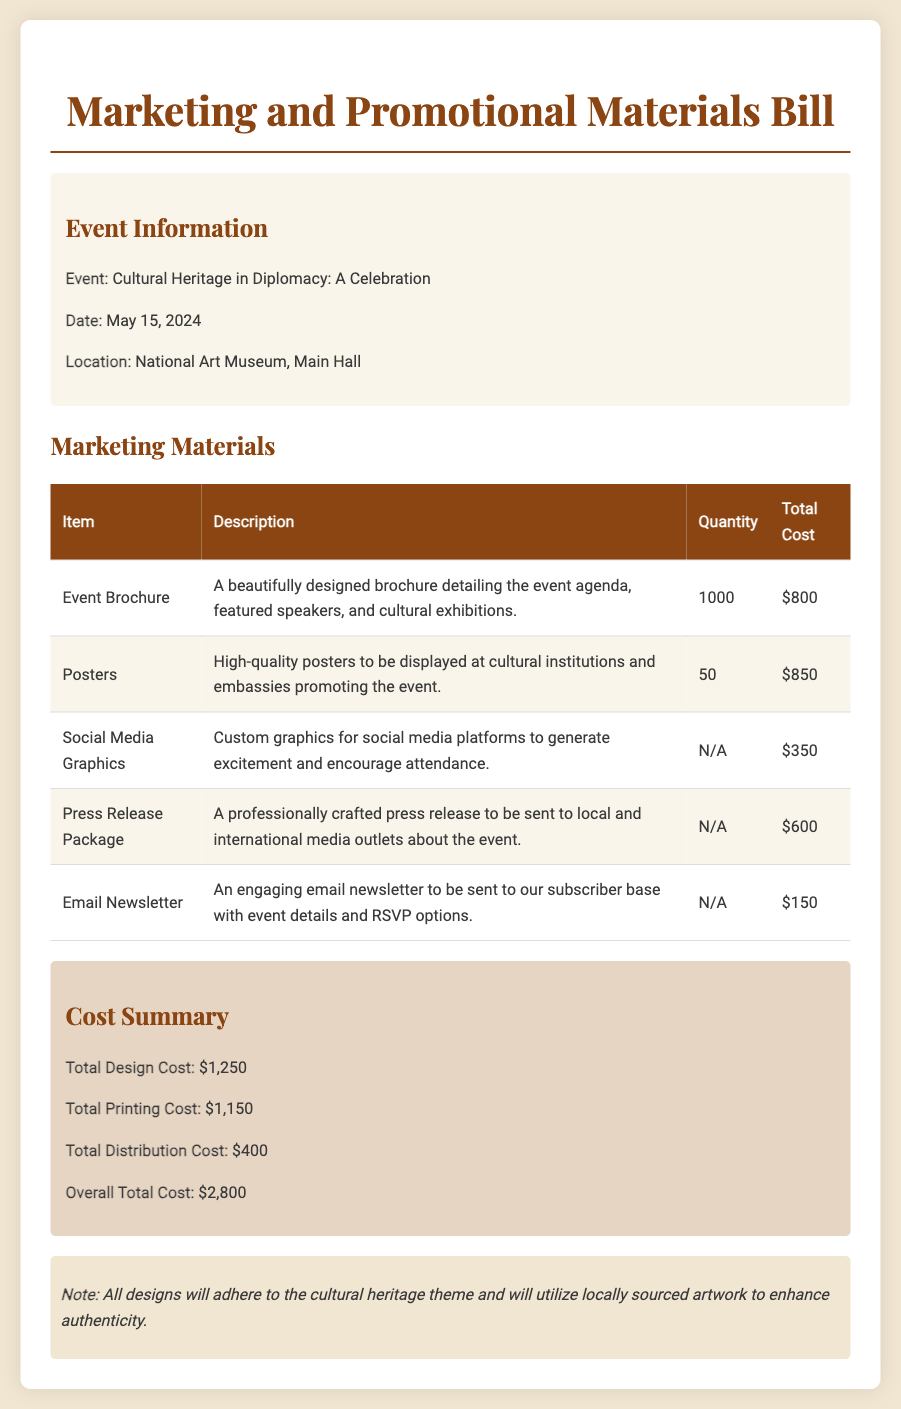What is the event title? The event title is specified in the document as "Cultural Heritage in Diplomacy: A Celebration."
Answer: Cultural Heritage in Diplomacy: A Celebration What is the date of the event? The date of the event is clearly mentioned in the document.
Answer: May 15, 2024 How many brochures will be printed? The document specifies the quantity of brochures to be printed.
Answer: 1000 What is the total cost for printing posters? The total cost for posters is detailed in the table within the document.
Answer: $850 What is the overall total cost for marketing materials? The overall total cost is summarized at the end of the document in the cost summary section.
Answer: $2,800 What is included in the press release package? The description explains that it is a professionally crafted press release sent to media outlets.
Answer: Professionally crafted press release What is the total design cost? The total design cost is given in the cost summary section of the document.
Answer: $1,250 How many posters will be printed? The quantity of posters printed is stated in the marketing materials section.
Answer: 50 What theme will the designs adhere to? The note at the bottom of the document specifies the theme of the designs.
Answer: Cultural heritage theme 